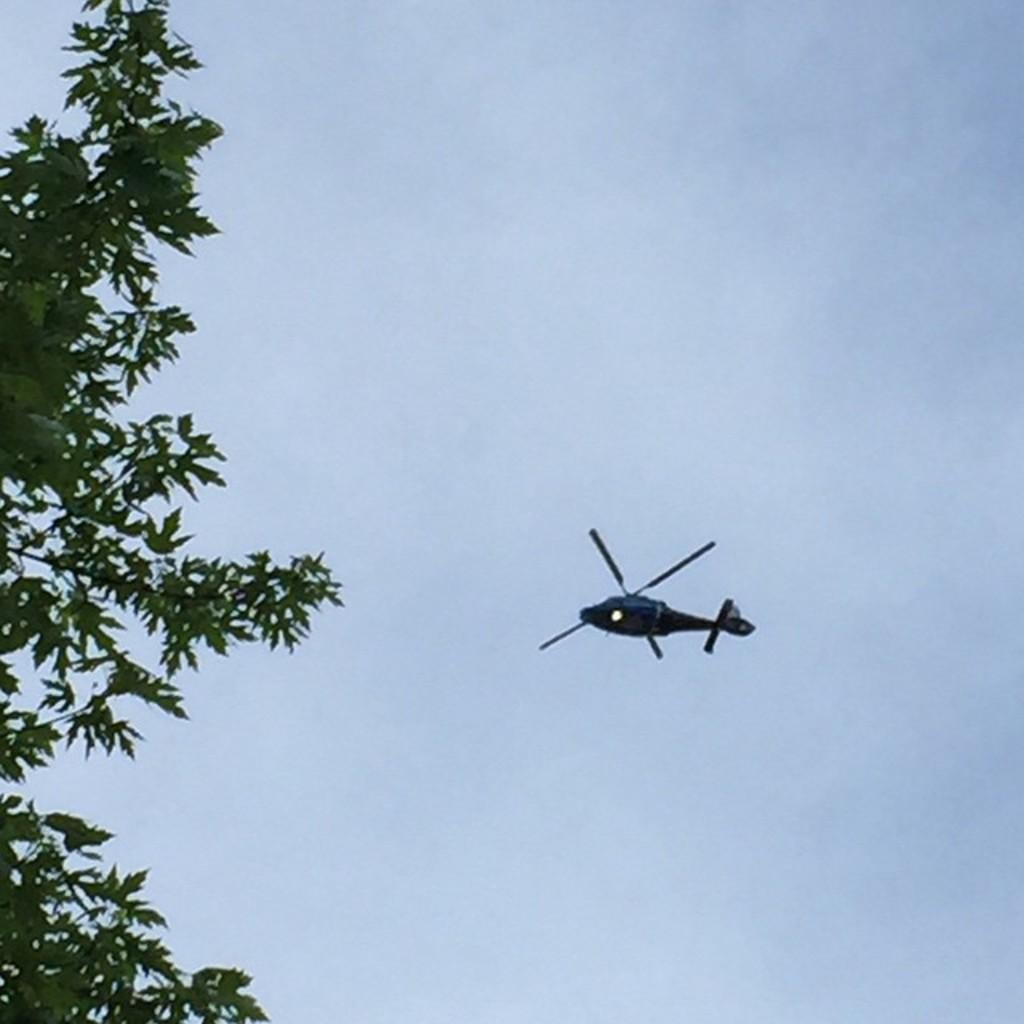How would you summarize this image in a sentence or two? In this image I can see a helicopter flying in the air towards the left side. On the left side few leaves are visible. In the background, I can see the sky. 